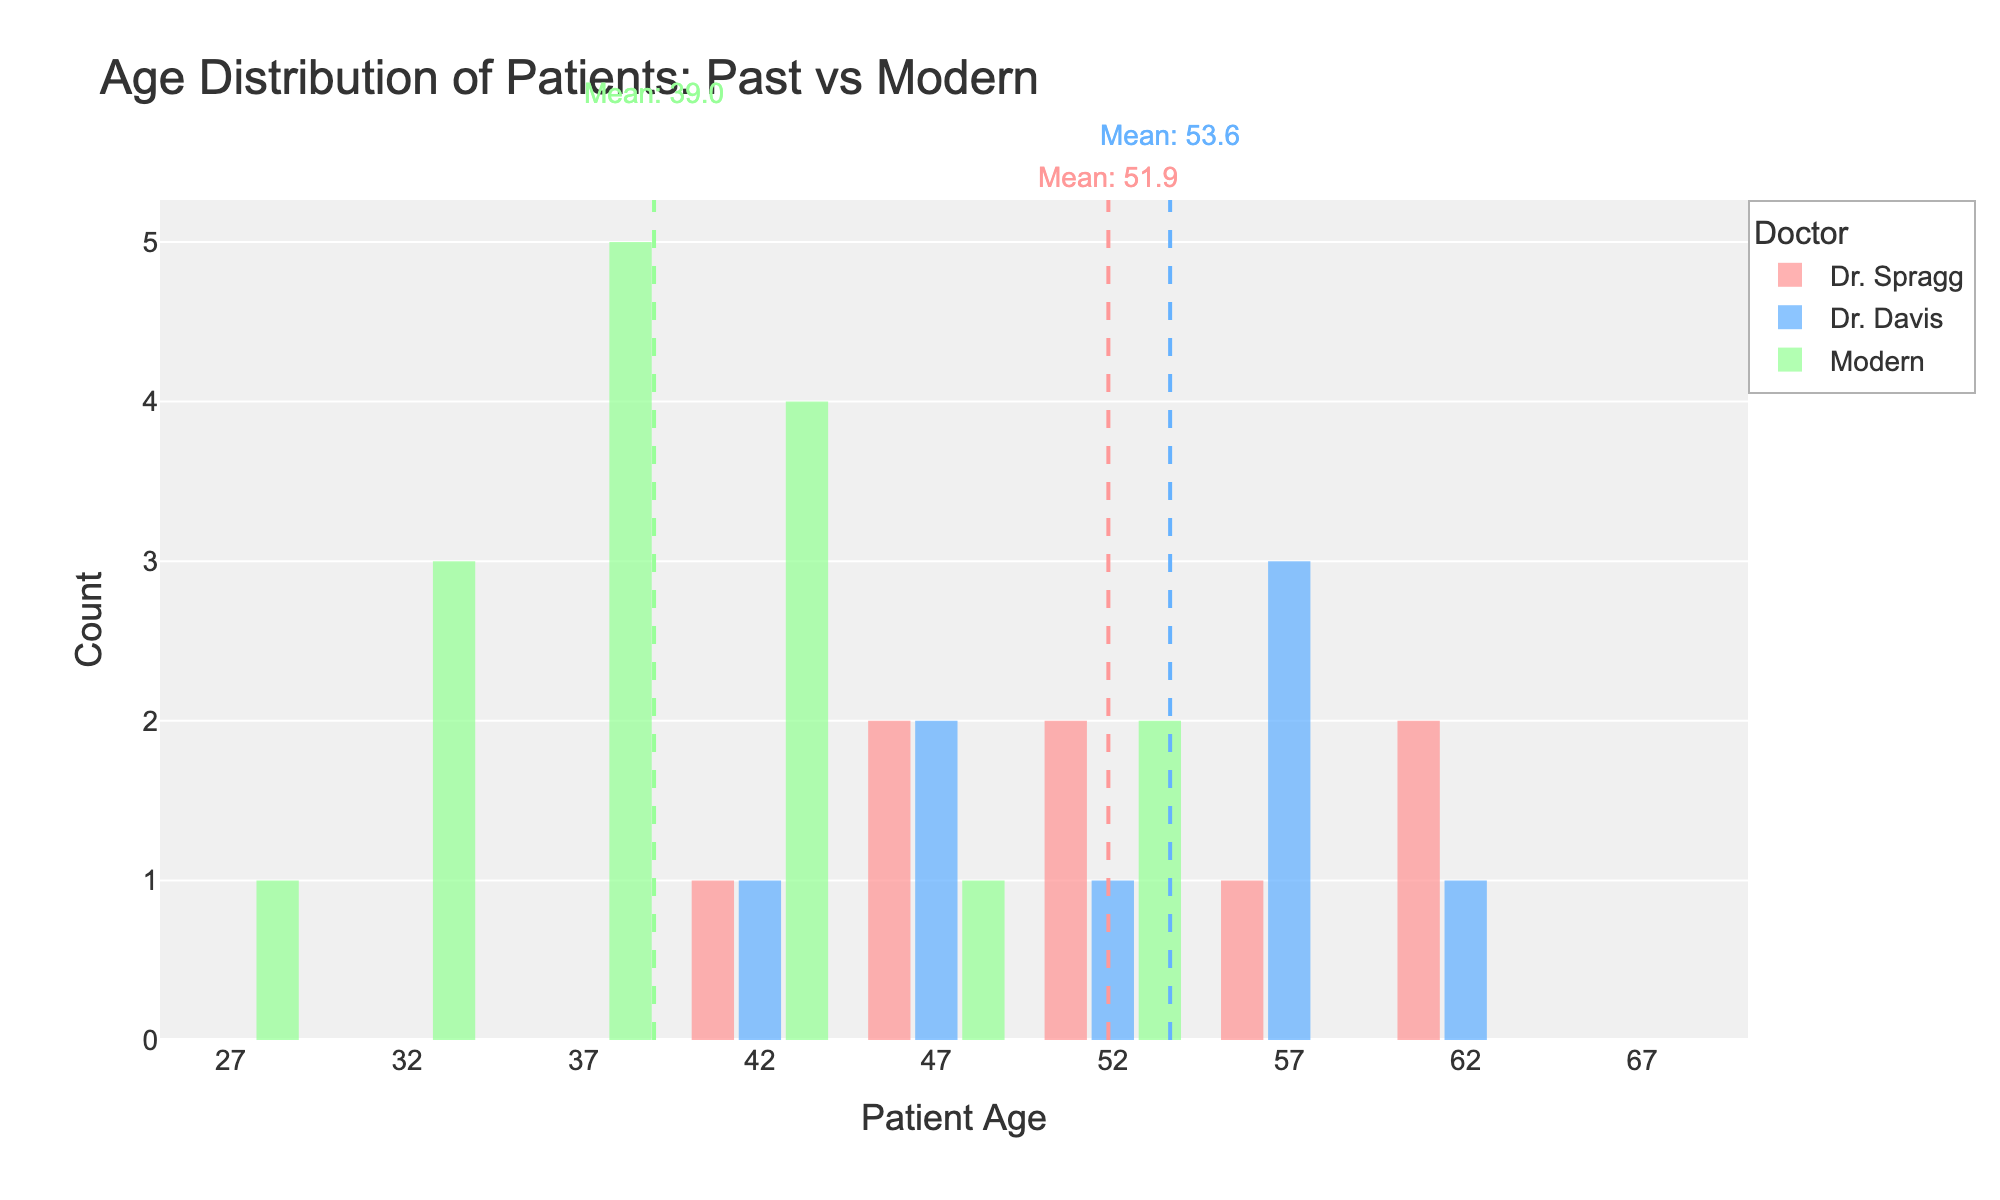What's the title of the figure? The title of the figure is positioned at the top. It states the main focus of the figure.
Answer: Age Distribution of Patients: Past vs Modern How many patients were treated by Dr. Spragg, according to the figure? By counting the data points/groups shown in Dr. Spragg's distribution, we can see how many patients' ages are displayed.
Answer: 8 Which group has the highest mean age? By looking at the dashed lines indicating the mean age, we observe the position of each group's mean value. The highest mean is marked by a dashed line to the rightmost side of the distribution.
Answer: Dr. Davis What is the approximate mean age of patients treated by Dr. Davis? The mean age is indicated by a dashed line within Dr. Davis' distribution and annotated above it.
Answer: 53.6 What's the mean age of modern-day patients? The mean age for modern-day patients is indicated by a green dashed line and annotated above it.
Answer: 38.9 What age range covers the majority of patients treated by Dr. Spragg? This can be identified by looking at where most of the histogram bars for Dr. Spragg lie. We see a concentration in a specific age range.
Answer: 41 to 62 Comparing Dr. Spragg and Dr. Davis' patients, which doctor treated younger patients on average? By comparing the positions of the dashed lines representing the mean ages, we can see which line is further to the left.
Answer: Dr. Spragg Do modern-day patients have a wider or narrower age range compared to past patients? By visually comparing the spread (width) of the histograms for modern-day patients and past patients (either Dr. Spragg or Dr. Davis), we determine the relative age range.
Answer: Wider How does the age distribution of patients treated by Dr. Johnson compare to those of Dr. Spragg? By comparing the histograms for Dr. Johnson and Dr. Spragg, we can see the differences in spread, peak, and central tendency. Dr. Johnson's patients fall in a younger range.
Answer: Younger Between Dr. Smith and Dr. Johnson, who treated older patients on average in modern times? By viewing the green histogram bars and their extensions, we find which doctor’s distribution of ages is centered more to the right.
Answer: Dr. Johnson 